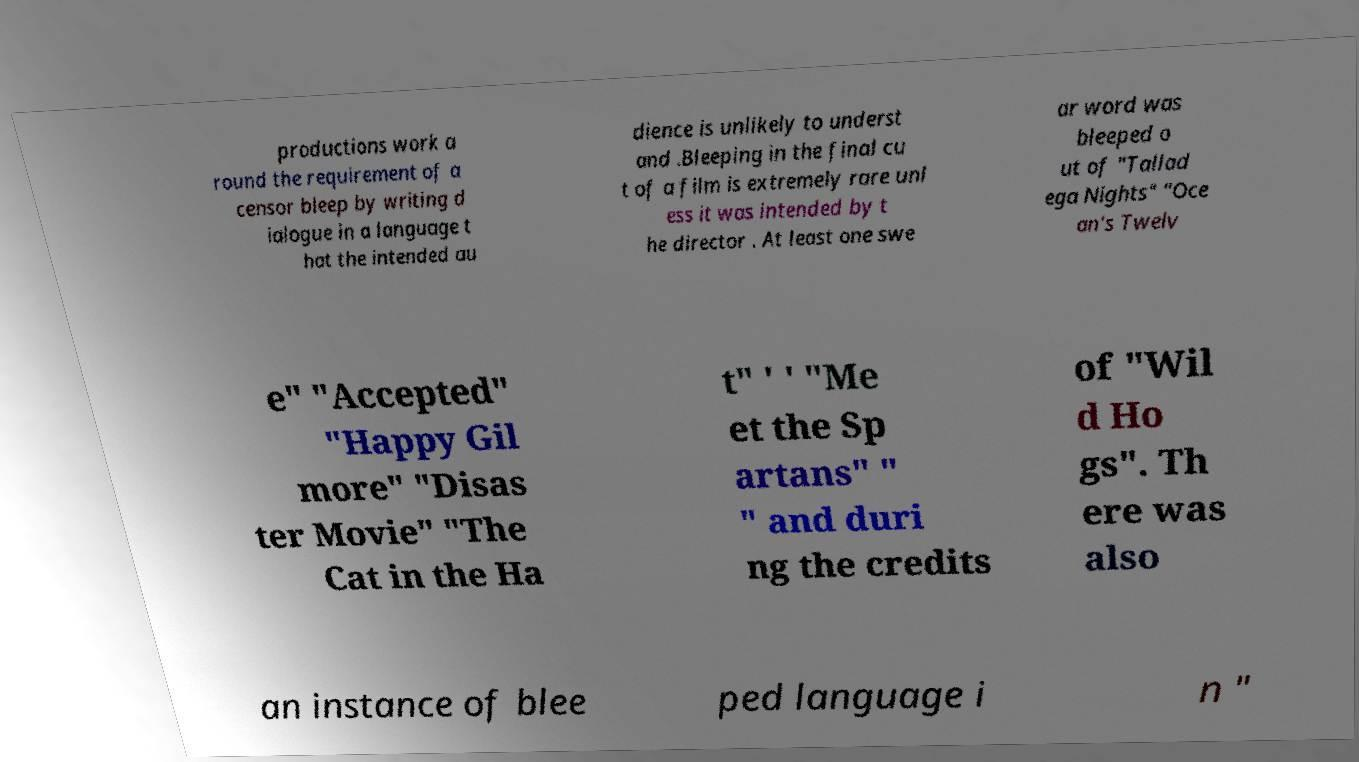Can you accurately transcribe the text from the provided image for me? productions work a round the requirement of a censor bleep by writing d ialogue in a language t hat the intended au dience is unlikely to underst and .Bleeping in the final cu t of a film is extremely rare unl ess it was intended by t he director . At least one swe ar word was bleeped o ut of "Tallad ega Nights" "Oce an's Twelv e" "Accepted" "Happy Gil more" "Disas ter Movie" "The Cat in the Ha t" ' ' "Me et the Sp artans" " " and duri ng the credits of "Wil d Ho gs". Th ere was also an instance of blee ped language i n " 